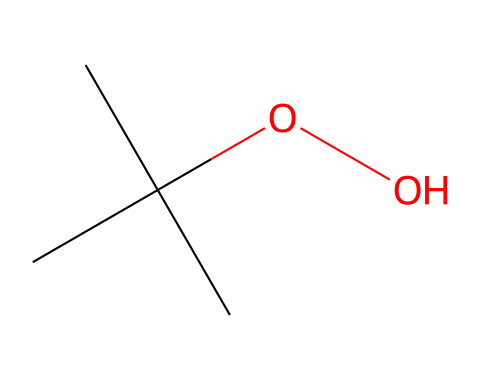What is the total number of carbon atoms in this molecule? By examining the SMILES representation, "CC(C)(C)OO", we can see there are three "C" directly connected and one additional "C" at the start, totaling four carbon atoms.
Answer: four How many hydrogen atoms are present in this compound? Each carbon in the molecule "CC(C)(C)OO" has bonded with enough hydrogen atoms to fulfill its tetravalent nature. The three branched carbons each have three hydrogen atoms, and the terminal carbon has two hydrogens. Adding these gives a total of ten hydrogen atoms.
Answer: ten What is the functional group present in this molecule? The "OO" at the end of the SMILES indicates a hydroxyl group (-OH), which is characteristic of alcohols. This functional group is crucial for its properties as a sanitizing agent.
Answer: alcohol Is this molecule likely to be hydrophobic or hydrophilic? Given its alcohol functional group, which is polar, and the carbon backbone, this molecule will interact reasonably well with water, meaning it is hydrophilic.
Answer: hydrophilic What type of chemical is represented by this structure? The structure "CC(C)(C)OO" indicates it is an alcohol, specifically a tertiary alcohol due to the carbon with the hydroxyl being attached to three other carbon atoms.
Answer: tertiary alcohol How many oxygen atoms are in this molecule? The "OO" in the SMILES representation denotes two oxygen atoms, both associated with the functional group, confirming their count directly from the structure.
Answer: two 